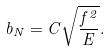Convert formula to latex. <formula><loc_0><loc_0><loc_500><loc_500>b _ { N } = C \sqrt { \frac { f ^ { 2 } } { E } } .</formula> 